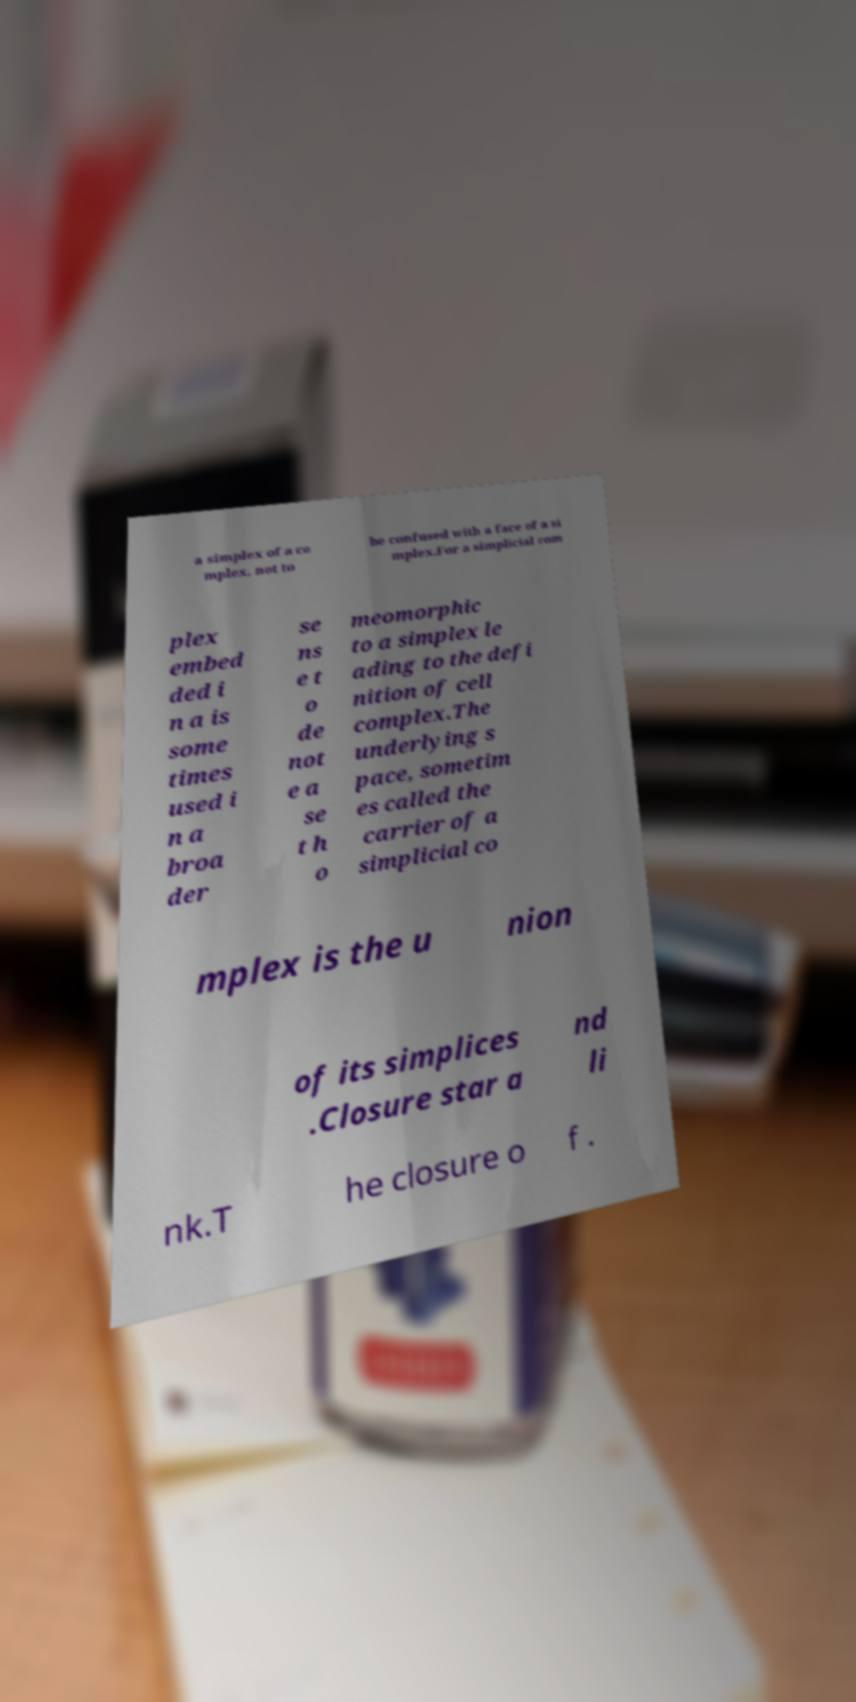Please identify and transcribe the text found in this image. a simplex of a co mplex, not to be confused with a face of a si mplex.For a simplicial com plex embed ded i n a is some times used i n a broa der se ns e t o de not e a se t h o meomorphic to a simplex le ading to the defi nition of cell complex.The underlying s pace, sometim es called the carrier of a simplicial co mplex is the u nion of its simplices .Closure star a nd li nk.T he closure o f . 